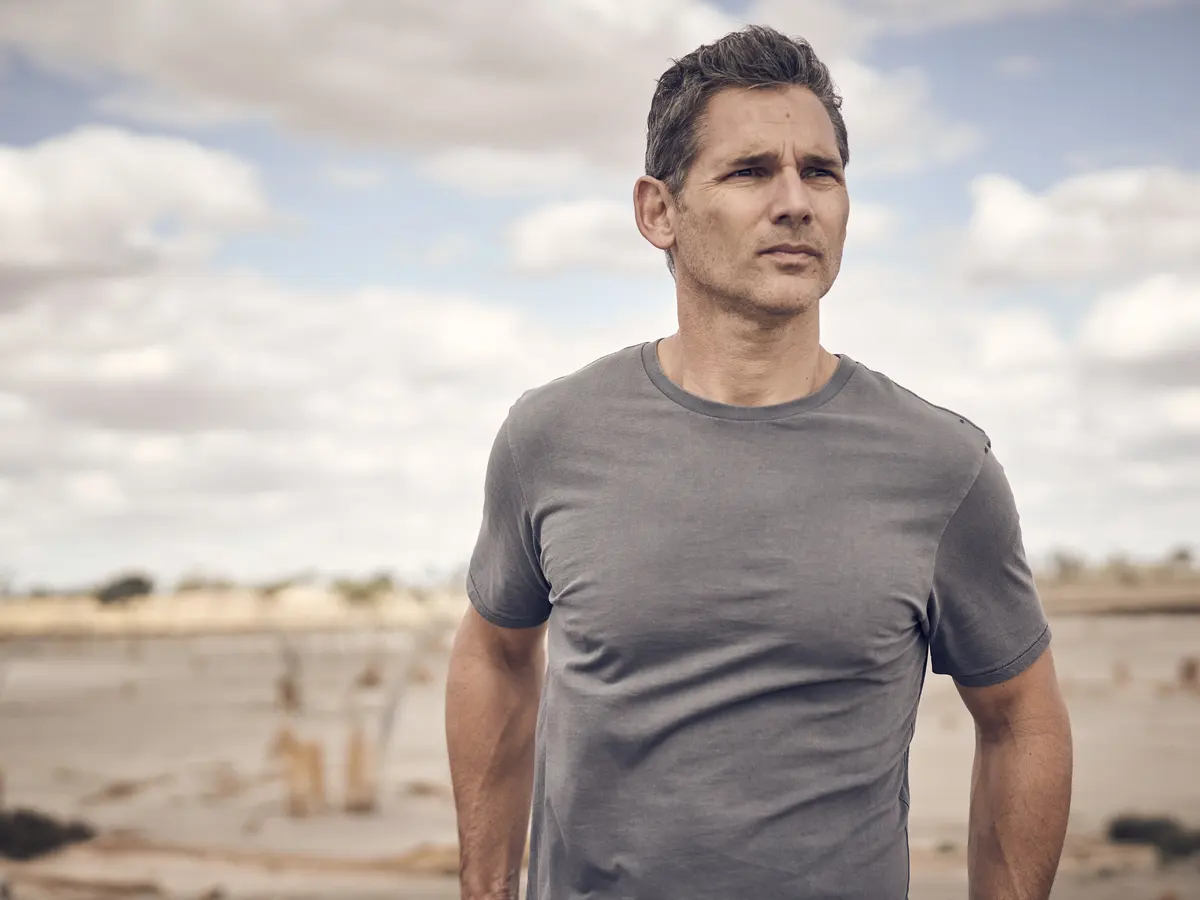Describe the mood and environment depicted in this image. The mood of the image is contemplative and serene. The man, dressed casually in a gray t-shirt, stands on a sandy beach under an overcast sky. His gaze is directed towards the horizon, suggesting deep thought or introspection. The cloudy sky and muted colors of the beach amplify the sense of solitude and calmness in the scene. 